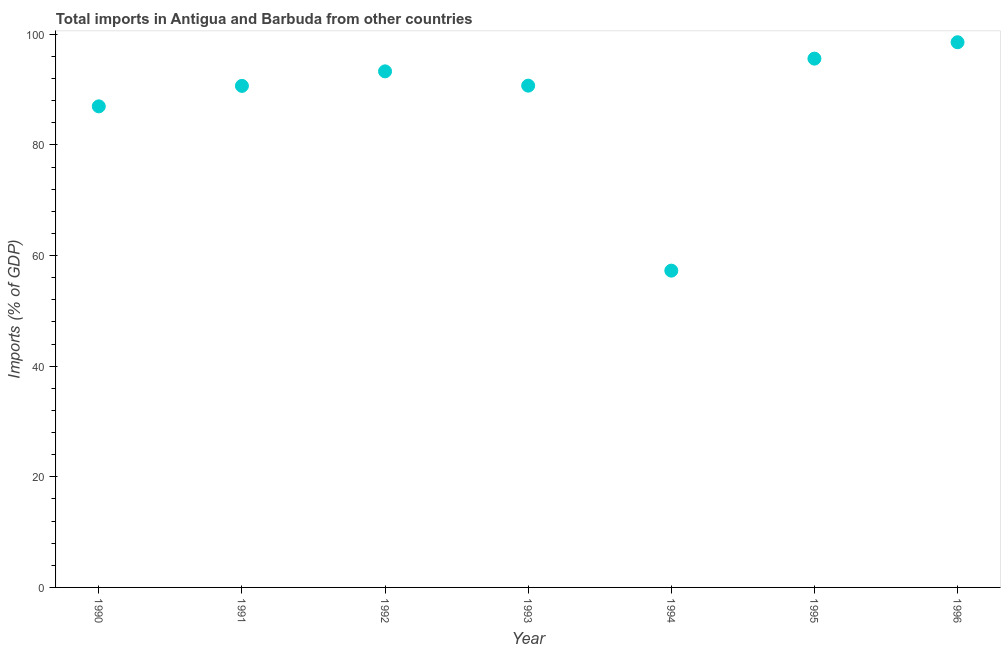What is the total imports in 1993?
Give a very brief answer. 90.72. Across all years, what is the maximum total imports?
Provide a succinct answer. 98.56. Across all years, what is the minimum total imports?
Offer a terse response. 57.27. In which year was the total imports maximum?
Ensure brevity in your answer.  1996. What is the sum of the total imports?
Offer a very short reply. 613.09. What is the difference between the total imports in 1990 and 1993?
Give a very brief answer. -3.74. What is the average total imports per year?
Offer a very short reply. 87.58. What is the median total imports?
Make the answer very short. 90.72. Do a majority of the years between 1993 and 1994 (inclusive) have total imports greater than 12 %?
Keep it short and to the point. Yes. What is the ratio of the total imports in 1992 to that in 1993?
Ensure brevity in your answer.  1.03. Is the total imports in 1990 less than that in 1993?
Offer a very short reply. Yes. What is the difference between the highest and the second highest total imports?
Ensure brevity in your answer.  2.96. What is the difference between the highest and the lowest total imports?
Provide a succinct answer. 41.29. Does the total imports monotonically increase over the years?
Ensure brevity in your answer.  No. How many dotlines are there?
Offer a terse response. 1. Does the graph contain any zero values?
Your answer should be compact. No. What is the title of the graph?
Your answer should be very brief. Total imports in Antigua and Barbuda from other countries. What is the label or title of the X-axis?
Offer a terse response. Year. What is the label or title of the Y-axis?
Make the answer very short. Imports (% of GDP). What is the Imports (% of GDP) in 1990?
Provide a short and direct response. 86.97. What is the Imports (% of GDP) in 1991?
Give a very brief answer. 90.67. What is the Imports (% of GDP) in 1992?
Keep it short and to the point. 93.3. What is the Imports (% of GDP) in 1993?
Your response must be concise. 90.72. What is the Imports (% of GDP) in 1994?
Offer a very short reply. 57.27. What is the Imports (% of GDP) in 1995?
Provide a succinct answer. 95.6. What is the Imports (% of GDP) in 1996?
Keep it short and to the point. 98.56. What is the difference between the Imports (% of GDP) in 1990 and 1991?
Make the answer very short. -3.7. What is the difference between the Imports (% of GDP) in 1990 and 1992?
Your answer should be compact. -6.33. What is the difference between the Imports (% of GDP) in 1990 and 1993?
Offer a terse response. -3.74. What is the difference between the Imports (% of GDP) in 1990 and 1994?
Keep it short and to the point. 29.7. What is the difference between the Imports (% of GDP) in 1990 and 1995?
Ensure brevity in your answer.  -8.63. What is the difference between the Imports (% of GDP) in 1990 and 1996?
Provide a succinct answer. -11.59. What is the difference between the Imports (% of GDP) in 1991 and 1992?
Your answer should be very brief. -2.63. What is the difference between the Imports (% of GDP) in 1991 and 1993?
Offer a terse response. -0.04. What is the difference between the Imports (% of GDP) in 1991 and 1994?
Give a very brief answer. 33.4. What is the difference between the Imports (% of GDP) in 1991 and 1995?
Provide a succinct answer. -4.93. What is the difference between the Imports (% of GDP) in 1991 and 1996?
Give a very brief answer. -7.89. What is the difference between the Imports (% of GDP) in 1992 and 1993?
Your answer should be very brief. 2.58. What is the difference between the Imports (% of GDP) in 1992 and 1994?
Give a very brief answer. 36.03. What is the difference between the Imports (% of GDP) in 1992 and 1995?
Keep it short and to the point. -2.3. What is the difference between the Imports (% of GDP) in 1992 and 1996?
Provide a short and direct response. -5.26. What is the difference between the Imports (% of GDP) in 1993 and 1994?
Ensure brevity in your answer.  33.44. What is the difference between the Imports (% of GDP) in 1993 and 1995?
Your answer should be compact. -4.89. What is the difference between the Imports (% of GDP) in 1993 and 1996?
Keep it short and to the point. -7.85. What is the difference between the Imports (% of GDP) in 1994 and 1995?
Ensure brevity in your answer.  -38.33. What is the difference between the Imports (% of GDP) in 1994 and 1996?
Offer a very short reply. -41.29. What is the difference between the Imports (% of GDP) in 1995 and 1996?
Ensure brevity in your answer.  -2.96. What is the ratio of the Imports (% of GDP) in 1990 to that in 1992?
Offer a terse response. 0.93. What is the ratio of the Imports (% of GDP) in 1990 to that in 1994?
Provide a short and direct response. 1.52. What is the ratio of the Imports (% of GDP) in 1990 to that in 1995?
Your answer should be compact. 0.91. What is the ratio of the Imports (% of GDP) in 1990 to that in 1996?
Your answer should be very brief. 0.88. What is the ratio of the Imports (% of GDP) in 1991 to that in 1993?
Offer a very short reply. 1. What is the ratio of the Imports (% of GDP) in 1991 to that in 1994?
Provide a short and direct response. 1.58. What is the ratio of the Imports (% of GDP) in 1991 to that in 1995?
Your response must be concise. 0.95. What is the ratio of the Imports (% of GDP) in 1992 to that in 1993?
Offer a very short reply. 1.03. What is the ratio of the Imports (% of GDP) in 1992 to that in 1994?
Offer a terse response. 1.63. What is the ratio of the Imports (% of GDP) in 1992 to that in 1995?
Your response must be concise. 0.98. What is the ratio of the Imports (% of GDP) in 1992 to that in 1996?
Ensure brevity in your answer.  0.95. What is the ratio of the Imports (% of GDP) in 1993 to that in 1994?
Make the answer very short. 1.58. What is the ratio of the Imports (% of GDP) in 1993 to that in 1995?
Provide a short and direct response. 0.95. What is the ratio of the Imports (% of GDP) in 1993 to that in 1996?
Your response must be concise. 0.92. What is the ratio of the Imports (% of GDP) in 1994 to that in 1995?
Provide a succinct answer. 0.6. What is the ratio of the Imports (% of GDP) in 1994 to that in 1996?
Provide a succinct answer. 0.58. 